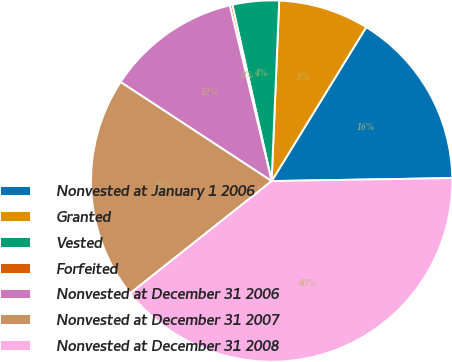<chart> <loc_0><loc_0><loc_500><loc_500><pie_chart><fcel>Nonvested at January 1 2006<fcel>Granted<fcel>Vested<fcel>Forfeited<fcel>Nonvested at December 31 2006<fcel>Nonvested at December 31 2007<fcel>Nonvested at December 31 2008<nl><fcel>15.97%<fcel>8.1%<fcel>4.16%<fcel>0.23%<fcel>12.04%<fcel>19.91%<fcel>39.59%<nl></chart> 